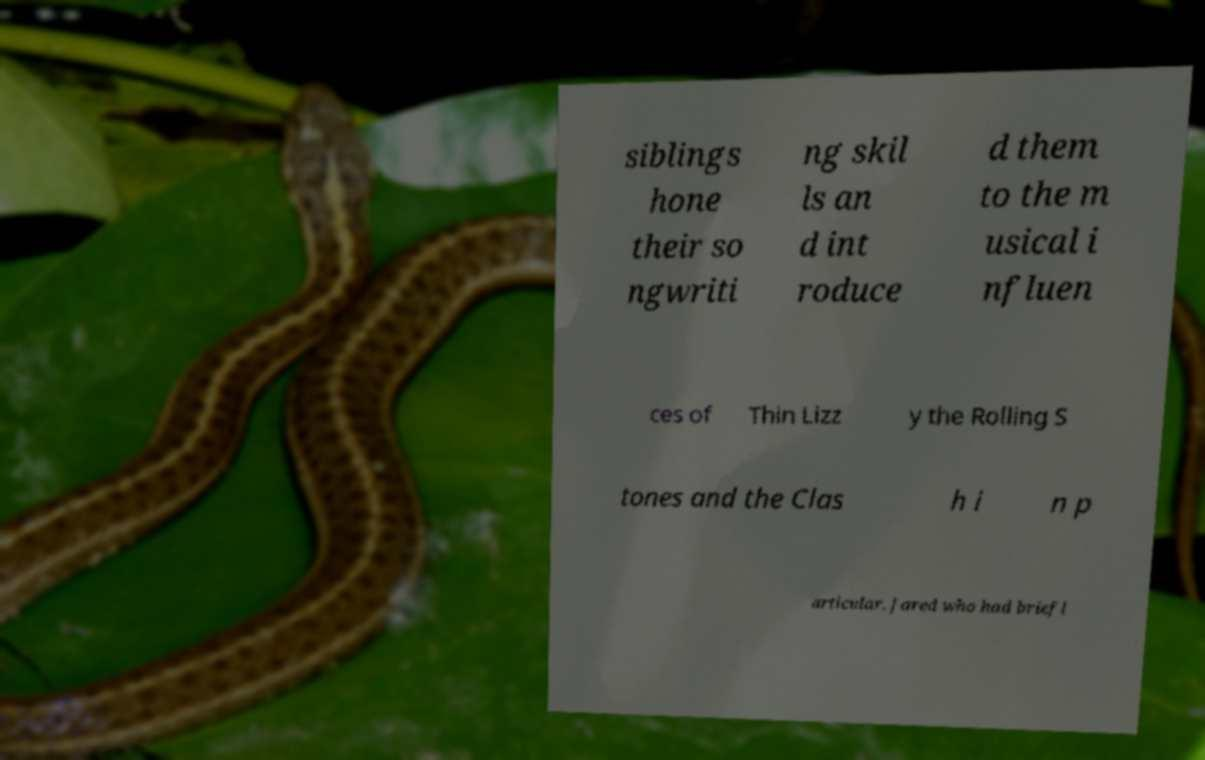What messages or text are displayed in this image? I need them in a readable, typed format. siblings hone their so ngwriti ng skil ls an d int roduce d them to the m usical i nfluen ces of Thin Lizz y the Rolling S tones and the Clas h i n p articular. Jared who had briefl 